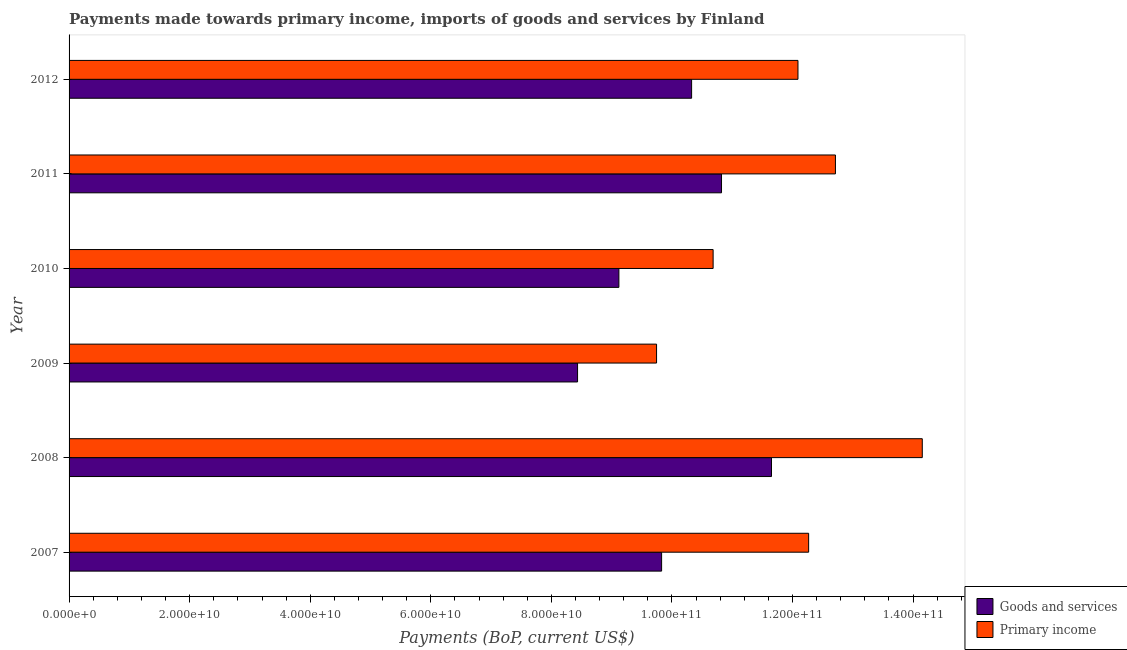How many groups of bars are there?
Offer a very short reply. 6. Are the number of bars on each tick of the Y-axis equal?
Offer a terse response. Yes. How many bars are there on the 4th tick from the top?
Provide a short and direct response. 2. How many bars are there on the 1st tick from the bottom?
Give a very brief answer. 2. What is the label of the 4th group of bars from the top?
Your answer should be compact. 2009. In how many cases, is the number of bars for a given year not equal to the number of legend labels?
Provide a short and direct response. 0. What is the payments made towards primary income in 2007?
Provide a succinct answer. 1.23e+11. Across all years, what is the maximum payments made towards goods and services?
Make the answer very short. 1.17e+11. Across all years, what is the minimum payments made towards goods and services?
Your response must be concise. 8.43e+1. In which year was the payments made towards goods and services minimum?
Give a very brief answer. 2009. What is the total payments made towards goods and services in the graph?
Your answer should be compact. 6.02e+11. What is the difference between the payments made towards primary income in 2008 and that in 2009?
Keep it short and to the point. 4.41e+1. What is the difference between the payments made towards primary income in 2009 and the payments made towards goods and services in 2008?
Provide a succinct answer. -1.91e+1. What is the average payments made towards goods and services per year?
Provide a short and direct response. 1.00e+11. In the year 2010, what is the difference between the payments made towards primary income and payments made towards goods and services?
Give a very brief answer. 1.56e+1. In how many years, is the payments made towards goods and services greater than 36000000000 US$?
Your response must be concise. 6. What is the ratio of the payments made towards primary income in 2011 to that in 2012?
Offer a terse response. 1.05. What is the difference between the highest and the second highest payments made towards primary income?
Your answer should be compact. 1.44e+1. What is the difference between the highest and the lowest payments made towards goods and services?
Give a very brief answer. 3.22e+1. In how many years, is the payments made towards primary income greater than the average payments made towards primary income taken over all years?
Offer a terse response. 4. Is the sum of the payments made towards goods and services in 2009 and 2010 greater than the maximum payments made towards primary income across all years?
Provide a succinct answer. Yes. What does the 1st bar from the top in 2010 represents?
Your answer should be compact. Primary income. What does the 1st bar from the bottom in 2007 represents?
Make the answer very short. Goods and services. How many bars are there?
Make the answer very short. 12. Are all the bars in the graph horizontal?
Keep it short and to the point. Yes. How many years are there in the graph?
Keep it short and to the point. 6. What is the difference between two consecutive major ticks on the X-axis?
Give a very brief answer. 2.00e+1. Are the values on the major ticks of X-axis written in scientific E-notation?
Ensure brevity in your answer.  Yes. Where does the legend appear in the graph?
Give a very brief answer. Bottom right. How many legend labels are there?
Offer a very short reply. 2. How are the legend labels stacked?
Keep it short and to the point. Vertical. What is the title of the graph?
Ensure brevity in your answer.  Payments made towards primary income, imports of goods and services by Finland. Does "Infant" appear as one of the legend labels in the graph?
Your answer should be compact. No. What is the label or title of the X-axis?
Give a very brief answer. Payments (BoP, current US$). What is the label or title of the Y-axis?
Your answer should be compact. Year. What is the Payments (BoP, current US$) of Goods and services in 2007?
Keep it short and to the point. 9.83e+1. What is the Payments (BoP, current US$) in Primary income in 2007?
Your answer should be compact. 1.23e+11. What is the Payments (BoP, current US$) in Goods and services in 2008?
Ensure brevity in your answer.  1.17e+11. What is the Payments (BoP, current US$) of Primary income in 2008?
Make the answer very short. 1.42e+11. What is the Payments (BoP, current US$) of Goods and services in 2009?
Your response must be concise. 8.43e+1. What is the Payments (BoP, current US$) of Primary income in 2009?
Your response must be concise. 9.74e+1. What is the Payments (BoP, current US$) in Goods and services in 2010?
Make the answer very short. 9.12e+1. What is the Payments (BoP, current US$) in Primary income in 2010?
Offer a very short reply. 1.07e+11. What is the Payments (BoP, current US$) of Goods and services in 2011?
Offer a very short reply. 1.08e+11. What is the Payments (BoP, current US$) in Primary income in 2011?
Provide a succinct answer. 1.27e+11. What is the Payments (BoP, current US$) of Goods and services in 2012?
Offer a terse response. 1.03e+11. What is the Payments (BoP, current US$) of Primary income in 2012?
Provide a short and direct response. 1.21e+11. Across all years, what is the maximum Payments (BoP, current US$) of Goods and services?
Your answer should be very brief. 1.17e+11. Across all years, what is the maximum Payments (BoP, current US$) in Primary income?
Give a very brief answer. 1.42e+11. Across all years, what is the minimum Payments (BoP, current US$) of Goods and services?
Provide a succinct answer. 8.43e+1. Across all years, what is the minimum Payments (BoP, current US$) in Primary income?
Ensure brevity in your answer.  9.74e+1. What is the total Payments (BoP, current US$) in Goods and services in the graph?
Your answer should be compact. 6.02e+11. What is the total Payments (BoP, current US$) of Primary income in the graph?
Offer a terse response. 7.16e+11. What is the difference between the Payments (BoP, current US$) of Goods and services in 2007 and that in 2008?
Provide a succinct answer. -1.82e+1. What is the difference between the Payments (BoP, current US$) in Primary income in 2007 and that in 2008?
Your answer should be compact. -1.89e+1. What is the difference between the Payments (BoP, current US$) of Goods and services in 2007 and that in 2009?
Make the answer very short. 1.39e+1. What is the difference between the Payments (BoP, current US$) of Primary income in 2007 and that in 2009?
Make the answer very short. 2.52e+1. What is the difference between the Payments (BoP, current US$) of Goods and services in 2007 and that in 2010?
Your answer should be compact. 7.09e+09. What is the difference between the Payments (BoP, current US$) of Primary income in 2007 and that in 2010?
Your answer should be very brief. 1.58e+1. What is the difference between the Payments (BoP, current US$) in Goods and services in 2007 and that in 2011?
Offer a very short reply. -9.94e+09. What is the difference between the Payments (BoP, current US$) in Primary income in 2007 and that in 2011?
Provide a succinct answer. -4.45e+09. What is the difference between the Payments (BoP, current US$) of Goods and services in 2007 and that in 2012?
Your response must be concise. -4.98e+09. What is the difference between the Payments (BoP, current US$) of Primary income in 2007 and that in 2012?
Ensure brevity in your answer.  1.77e+09. What is the difference between the Payments (BoP, current US$) in Goods and services in 2008 and that in 2009?
Give a very brief answer. 3.22e+1. What is the difference between the Payments (BoP, current US$) of Primary income in 2008 and that in 2009?
Your answer should be very brief. 4.41e+1. What is the difference between the Payments (BoP, current US$) in Goods and services in 2008 and that in 2010?
Ensure brevity in your answer.  2.53e+1. What is the difference between the Payments (BoP, current US$) in Primary income in 2008 and that in 2010?
Provide a succinct answer. 3.47e+1. What is the difference between the Payments (BoP, current US$) of Goods and services in 2008 and that in 2011?
Make the answer very short. 8.29e+09. What is the difference between the Payments (BoP, current US$) in Primary income in 2008 and that in 2011?
Your answer should be compact. 1.44e+1. What is the difference between the Payments (BoP, current US$) in Goods and services in 2008 and that in 2012?
Keep it short and to the point. 1.32e+1. What is the difference between the Payments (BoP, current US$) in Primary income in 2008 and that in 2012?
Provide a short and direct response. 2.06e+1. What is the difference between the Payments (BoP, current US$) in Goods and services in 2009 and that in 2010?
Keep it short and to the point. -6.85e+09. What is the difference between the Payments (BoP, current US$) in Primary income in 2009 and that in 2010?
Your response must be concise. -9.38e+09. What is the difference between the Payments (BoP, current US$) in Goods and services in 2009 and that in 2011?
Give a very brief answer. -2.39e+1. What is the difference between the Payments (BoP, current US$) of Primary income in 2009 and that in 2011?
Provide a succinct answer. -2.97e+1. What is the difference between the Payments (BoP, current US$) of Goods and services in 2009 and that in 2012?
Your answer should be very brief. -1.89e+1. What is the difference between the Payments (BoP, current US$) of Primary income in 2009 and that in 2012?
Your answer should be compact. -2.35e+1. What is the difference between the Payments (BoP, current US$) of Goods and services in 2010 and that in 2011?
Give a very brief answer. -1.70e+1. What is the difference between the Payments (BoP, current US$) in Primary income in 2010 and that in 2011?
Provide a succinct answer. -2.03e+1. What is the difference between the Payments (BoP, current US$) of Goods and services in 2010 and that in 2012?
Offer a very short reply. -1.21e+1. What is the difference between the Payments (BoP, current US$) of Primary income in 2010 and that in 2012?
Provide a succinct answer. -1.41e+1. What is the difference between the Payments (BoP, current US$) of Goods and services in 2011 and that in 2012?
Give a very brief answer. 4.96e+09. What is the difference between the Payments (BoP, current US$) in Primary income in 2011 and that in 2012?
Your answer should be very brief. 6.22e+09. What is the difference between the Payments (BoP, current US$) in Goods and services in 2007 and the Payments (BoP, current US$) in Primary income in 2008?
Give a very brief answer. -4.32e+1. What is the difference between the Payments (BoP, current US$) in Goods and services in 2007 and the Payments (BoP, current US$) in Primary income in 2009?
Offer a terse response. 8.36e+08. What is the difference between the Payments (BoP, current US$) of Goods and services in 2007 and the Payments (BoP, current US$) of Primary income in 2010?
Offer a terse response. -8.55e+09. What is the difference between the Payments (BoP, current US$) of Goods and services in 2007 and the Payments (BoP, current US$) of Primary income in 2011?
Your answer should be very brief. -2.88e+1. What is the difference between the Payments (BoP, current US$) in Goods and services in 2007 and the Payments (BoP, current US$) in Primary income in 2012?
Provide a succinct answer. -2.26e+1. What is the difference between the Payments (BoP, current US$) of Goods and services in 2008 and the Payments (BoP, current US$) of Primary income in 2009?
Give a very brief answer. 1.91e+1. What is the difference between the Payments (BoP, current US$) in Goods and services in 2008 and the Payments (BoP, current US$) in Primary income in 2010?
Your answer should be very brief. 9.68e+09. What is the difference between the Payments (BoP, current US$) in Goods and services in 2008 and the Payments (BoP, current US$) in Primary income in 2011?
Provide a succinct answer. -1.06e+1. What is the difference between the Payments (BoP, current US$) in Goods and services in 2008 and the Payments (BoP, current US$) in Primary income in 2012?
Ensure brevity in your answer.  -4.39e+09. What is the difference between the Payments (BoP, current US$) in Goods and services in 2009 and the Payments (BoP, current US$) in Primary income in 2010?
Provide a succinct answer. -2.25e+1. What is the difference between the Payments (BoP, current US$) of Goods and services in 2009 and the Payments (BoP, current US$) of Primary income in 2011?
Keep it short and to the point. -4.28e+1. What is the difference between the Payments (BoP, current US$) of Goods and services in 2009 and the Payments (BoP, current US$) of Primary income in 2012?
Provide a short and direct response. -3.66e+1. What is the difference between the Payments (BoP, current US$) in Goods and services in 2010 and the Payments (BoP, current US$) in Primary income in 2011?
Ensure brevity in your answer.  -3.59e+1. What is the difference between the Payments (BoP, current US$) of Goods and services in 2010 and the Payments (BoP, current US$) of Primary income in 2012?
Provide a short and direct response. -2.97e+1. What is the difference between the Payments (BoP, current US$) in Goods and services in 2011 and the Payments (BoP, current US$) in Primary income in 2012?
Offer a terse response. -1.27e+1. What is the average Payments (BoP, current US$) in Goods and services per year?
Your response must be concise. 1.00e+11. What is the average Payments (BoP, current US$) of Primary income per year?
Make the answer very short. 1.19e+11. In the year 2007, what is the difference between the Payments (BoP, current US$) of Goods and services and Payments (BoP, current US$) of Primary income?
Offer a terse response. -2.44e+1. In the year 2008, what is the difference between the Payments (BoP, current US$) of Goods and services and Payments (BoP, current US$) of Primary income?
Your answer should be very brief. -2.50e+1. In the year 2009, what is the difference between the Payments (BoP, current US$) in Goods and services and Payments (BoP, current US$) in Primary income?
Provide a short and direct response. -1.31e+1. In the year 2010, what is the difference between the Payments (BoP, current US$) of Goods and services and Payments (BoP, current US$) of Primary income?
Offer a very short reply. -1.56e+1. In the year 2011, what is the difference between the Payments (BoP, current US$) of Goods and services and Payments (BoP, current US$) of Primary income?
Your answer should be very brief. -1.89e+1. In the year 2012, what is the difference between the Payments (BoP, current US$) in Goods and services and Payments (BoP, current US$) in Primary income?
Your answer should be very brief. -1.76e+1. What is the ratio of the Payments (BoP, current US$) of Goods and services in 2007 to that in 2008?
Keep it short and to the point. 0.84. What is the ratio of the Payments (BoP, current US$) of Primary income in 2007 to that in 2008?
Give a very brief answer. 0.87. What is the ratio of the Payments (BoP, current US$) of Goods and services in 2007 to that in 2009?
Provide a short and direct response. 1.17. What is the ratio of the Payments (BoP, current US$) in Primary income in 2007 to that in 2009?
Offer a very short reply. 1.26. What is the ratio of the Payments (BoP, current US$) of Goods and services in 2007 to that in 2010?
Give a very brief answer. 1.08. What is the ratio of the Payments (BoP, current US$) of Primary income in 2007 to that in 2010?
Your answer should be compact. 1.15. What is the ratio of the Payments (BoP, current US$) of Goods and services in 2007 to that in 2011?
Offer a terse response. 0.91. What is the ratio of the Payments (BoP, current US$) in Primary income in 2007 to that in 2011?
Offer a very short reply. 0.96. What is the ratio of the Payments (BoP, current US$) in Goods and services in 2007 to that in 2012?
Your response must be concise. 0.95. What is the ratio of the Payments (BoP, current US$) in Primary income in 2007 to that in 2012?
Your response must be concise. 1.01. What is the ratio of the Payments (BoP, current US$) in Goods and services in 2008 to that in 2009?
Offer a very short reply. 1.38. What is the ratio of the Payments (BoP, current US$) of Primary income in 2008 to that in 2009?
Your answer should be very brief. 1.45. What is the ratio of the Payments (BoP, current US$) of Goods and services in 2008 to that in 2010?
Ensure brevity in your answer.  1.28. What is the ratio of the Payments (BoP, current US$) in Primary income in 2008 to that in 2010?
Provide a short and direct response. 1.32. What is the ratio of the Payments (BoP, current US$) in Goods and services in 2008 to that in 2011?
Your response must be concise. 1.08. What is the ratio of the Payments (BoP, current US$) in Primary income in 2008 to that in 2011?
Ensure brevity in your answer.  1.11. What is the ratio of the Payments (BoP, current US$) in Goods and services in 2008 to that in 2012?
Offer a very short reply. 1.13. What is the ratio of the Payments (BoP, current US$) in Primary income in 2008 to that in 2012?
Your answer should be very brief. 1.17. What is the ratio of the Payments (BoP, current US$) of Goods and services in 2009 to that in 2010?
Offer a terse response. 0.92. What is the ratio of the Payments (BoP, current US$) in Primary income in 2009 to that in 2010?
Ensure brevity in your answer.  0.91. What is the ratio of the Payments (BoP, current US$) of Goods and services in 2009 to that in 2011?
Keep it short and to the point. 0.78. What is the ratio of the Payments (BoP, current US$) in Primary income in 2009 to that in 2011?
Offer a terse response. 0.77. What is the ratio of the Payments (BoP, current US$) in Goods and services in 2009 to that in 2012?
Ensure brevity in your answer.  0.82. What is the ratio of the Payments (BoP, current US$) of Primary income in 2009 to that in 2012?
Offer a terse response. 0.81. What is the ratio of the Payments (BoP, current US$) of Goods and services in 2010 to that in 2011?
Make the answer very short. 0.84. What is the ratio of the Payments (BoP, current US$) in Primary income in 2010 to that in 2011?
Provide a short and direct response. 0.84. What is the ratio of the Payments (BoP, current US$) in Goods and services in 2010 to that in 2012?
Your answer should be very brief. 0.88. What is the ratio of the Payments (BoP, current US$) in Primary income in 2010 to that in 2012?
Give a very brief answer. 0.88. What is the ratio of the Payments (BoP, current US$) of Goods and services in 2011 to that in 2012?
Keep it short and to the point. 1.05. What is the ratio of the Payments (BoP, current US$) in Primary income in 2011 to that in 2012?
Your answer should be compact. 1.05. What is the difference between the highest and the second highest Payments (BoP, current US$) of Goods and services?
Your response must be concise. 8.29e+09. What is the difference between the highest and the second highest Payments (BoP, current US$) in Primary income?
Make the answer very short. 1.44e+1. What is the difference between the highest and the lowest Payments (BoP, current US$) of Goods and services?
Your answer should be compact. 3.22e+1. What is the difference between the highest and the lowest Payments (BoP, current US$) of Primary income?
Offer a terse response. 4.41e+1. 